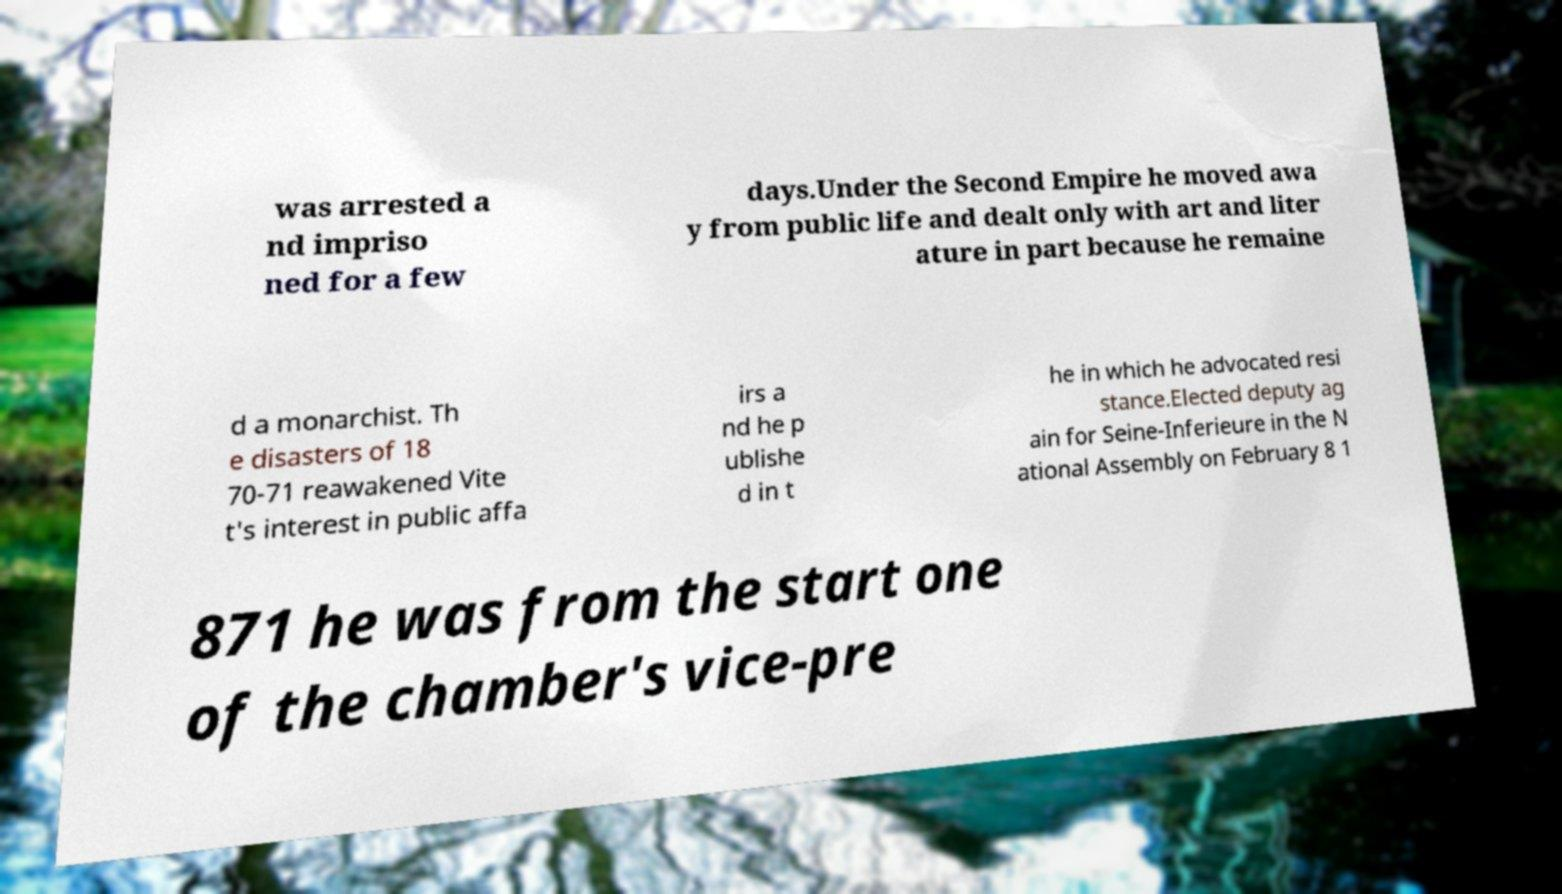Can you accurately transcribe the text from the provided image for me? was arrested a nd impriso ned for a few days.Under the Second Empire he moved awa y from public life and dealt only with art and liter ature in part because he remaine d a monarchist. Th e disasters of 18 70-71 reawakened Vite t's interest in public affa irs a nd he p ublishe d in t he in which he advocated resi stance.Elected deputy ag ain for Seine-Inferieure in the N ational Assembly on February 8 1 871 he was from the start one of the chamber's vice-pre 